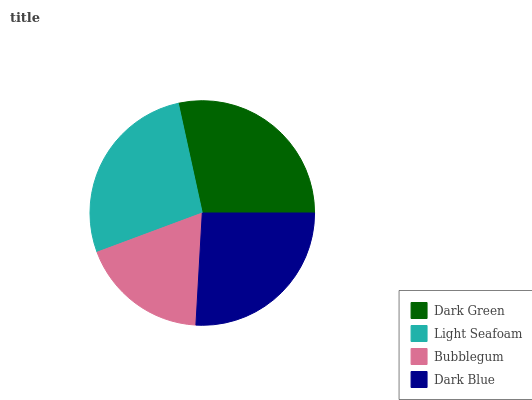Is Bubblegum the minimum?
Answer yes or no. Yes. Is Dark Green the maximum?
Answer yes or no. Yes. Is Light Seafoam the minimum?
Answer yes or no. No. Is Light Seafoam the maximum?
Answer yes or no. No. Is Dark Green greater than Light Seafoam?
Answer yes or no. Yes. Is Light Seafoam less than Dark Green?
Answer yes or no. Yes. Is Light Seafoam greater than Dark Green?
Answer yes or no. No. Is Dark Green less than Light Seafoam?
Answer yes or no. No. Is Light Seafoam the high median?
Answer yes or no. Yes. Is Dark Blue the low median?
Answer yes or no. Yes. Is Bubblegum the high median?
Answer yes or no. No. Is Dark Green the low median?
Answer yes or no. No. 